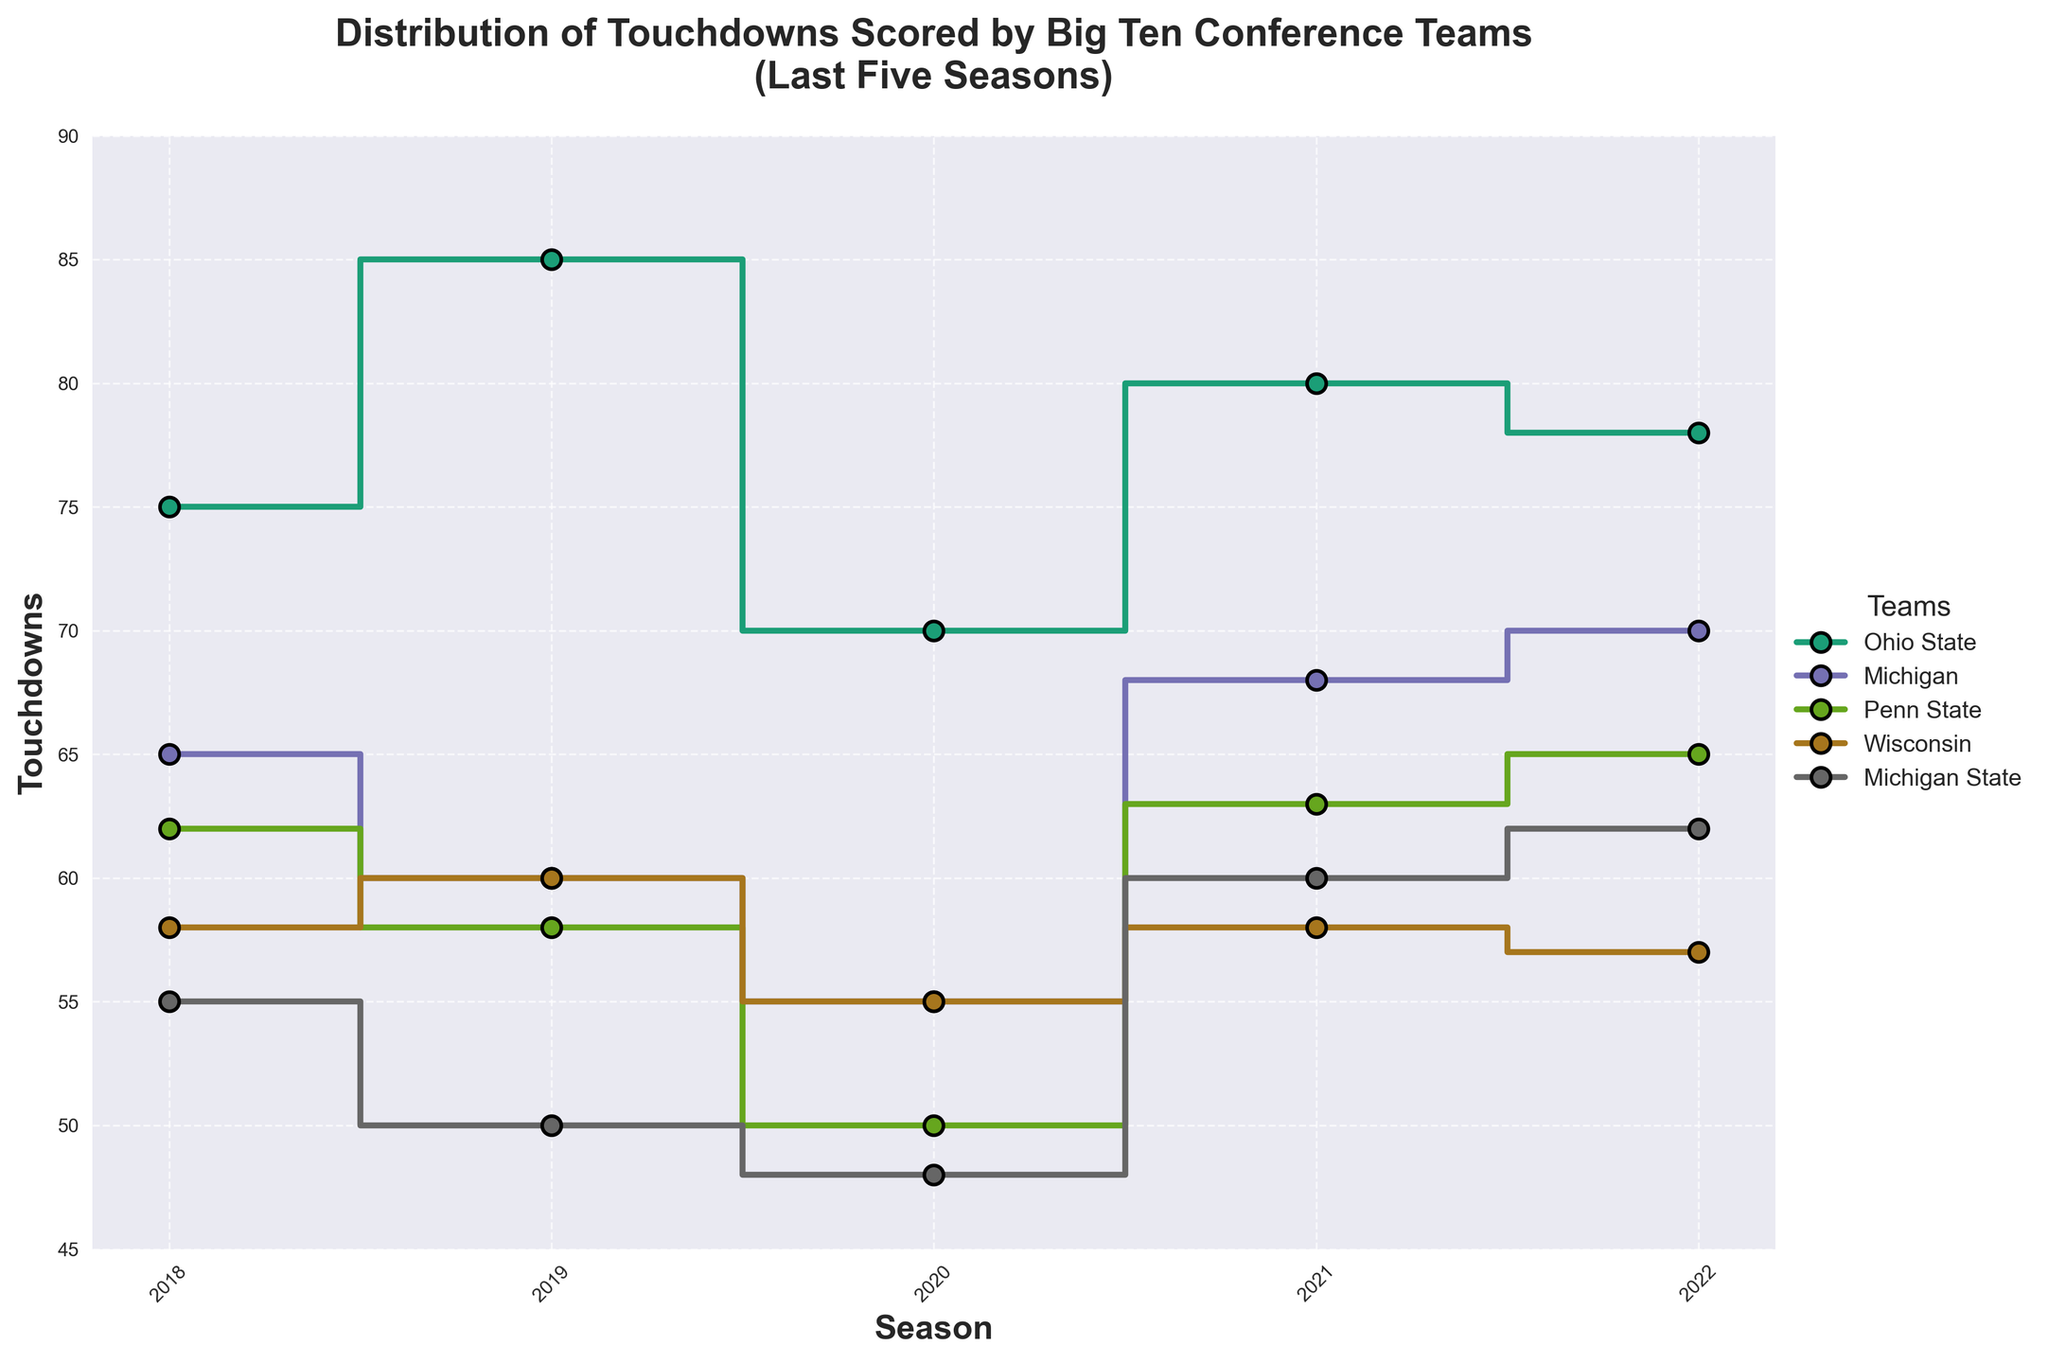What is the title of the figure? The title of the figure is located at the top center and summarizes the main objective of the plot.
Answer: Distribution of Touchdowns Scored by Big Ten Conference Teams (Last Five Seasons) Which team scored the highest number of touchdowns in any given season? To answer this, look at the highest point on any of the lines representing team touchdowns across the seasons.
Answer: Ohio State in 2019 What is the average number of touchdowns scored by Penn State over the last five seasons? Calculate the average by summing the touchdowns for Penn State (62 + 58 + 50 + 63 + 65) and dividing by 5. (62 + 58 + 50 + 63 + 65) / 5 = 298 / 5 = 59.6
Answer: 59.6 Which team had the smallest variation in touchdowns over the five seasons? Identify the team whose data points form a line that fluctuates the least in the vertical direction.
Answer: Wisconsin How does Michigan State's touchdown trend from 2018 to 2022 compare to that of Ohio State? Compare the general direction of the step lines for Michigan State and Ohio State from 2018 to 2022. Michigan State's line shows an overall increase, whereas Ohio State's remains high but fluctuates more.
Answer: Michigan State shows a general upward trend, while Ohio State fluctuates but remains high Which season had the highest cumulative touchdowns among all teams together? Sum the touchdowns for all teams for each season and identify the season with the highest total. 2018: (75+65+62+58+55), 2019: (85+60+58+60+50), 2020: (70+55+50+55+48), 2021: (80+68+63+58+60), 2022: (78+70+65+57+62).
Answer: 2019 Did any team have a consistent increase or decrease in touchdowns over the five seasons? Check the step lines for any team to see if they consistently go up or down each year without reversing direction.
Answer: No team had a consistent increase or decrease over all five seasons Compare the number of touchdowns scored by Wisconsin in 2018 and 2022. Observe the vertical positions of the step points for Wisconsin in 2018 and 2022 on the y-axis.
Answer: 58 in 2018 and 57 in 2022 Which team had the most variations in the number of touchdowns scored over the seasons? Identify the team whose step line shows the greatest fluctuation up and down.
Answer: Ohio State In which season did the touchdowns scored by Michigan first surpass those scored by Wisconsin? Trace the step lines for Michigan and Wisconsin and find the first instance where Michigan's line goes higher than Wisconsin's.
Answer: 2021 